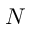<formula> <loc_0><loc_0><loc_500><loc_500>N</formula> 